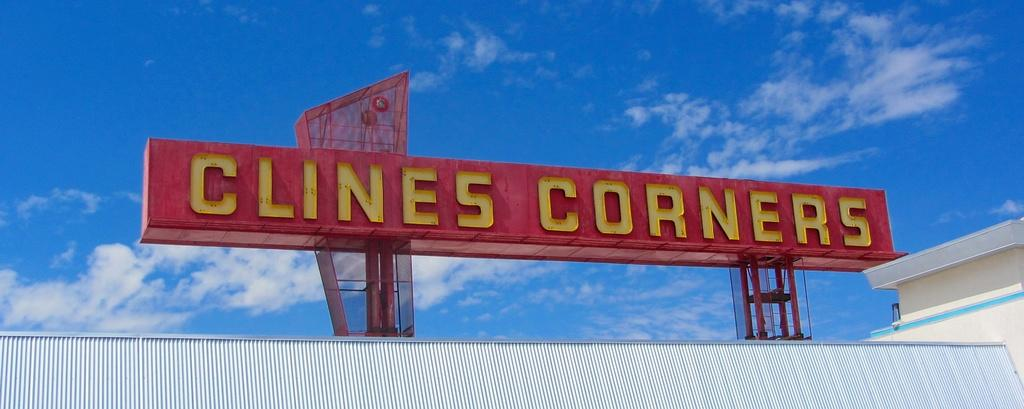<image>
Give a short and clear explanation of the subsequent image. A red sign that says Clines Corners in yellow wording 